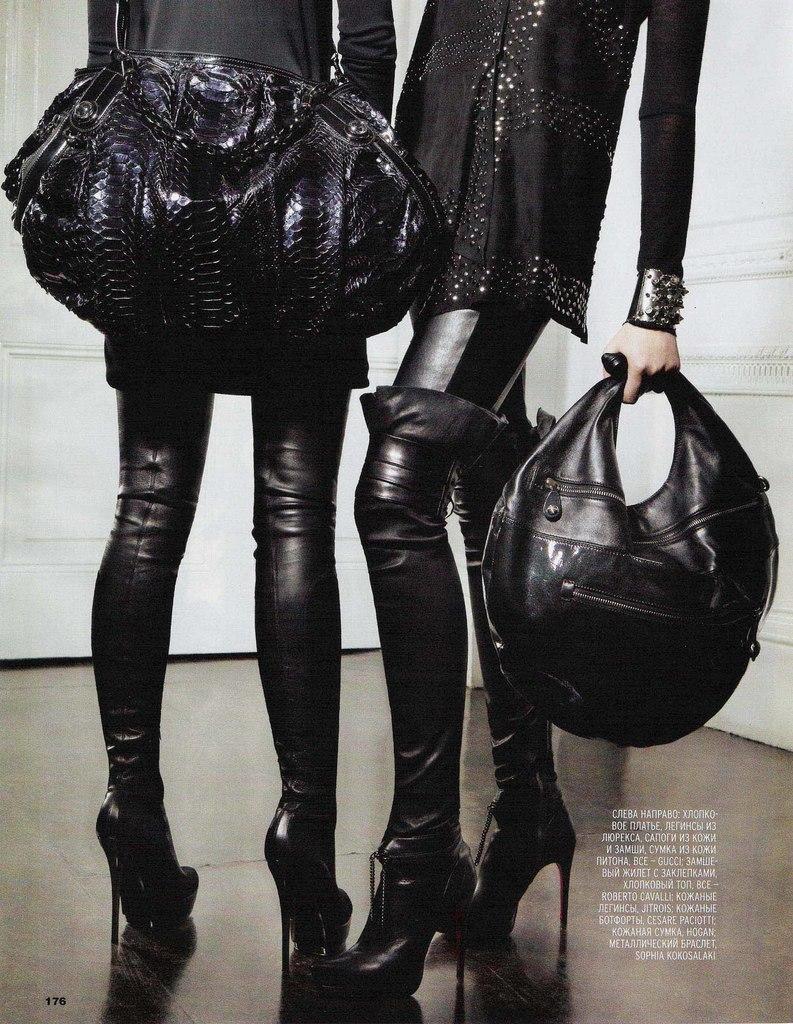How would you summarize this image in a sentence or two? There are two women wearing black dress and holding black bag in their hands. 